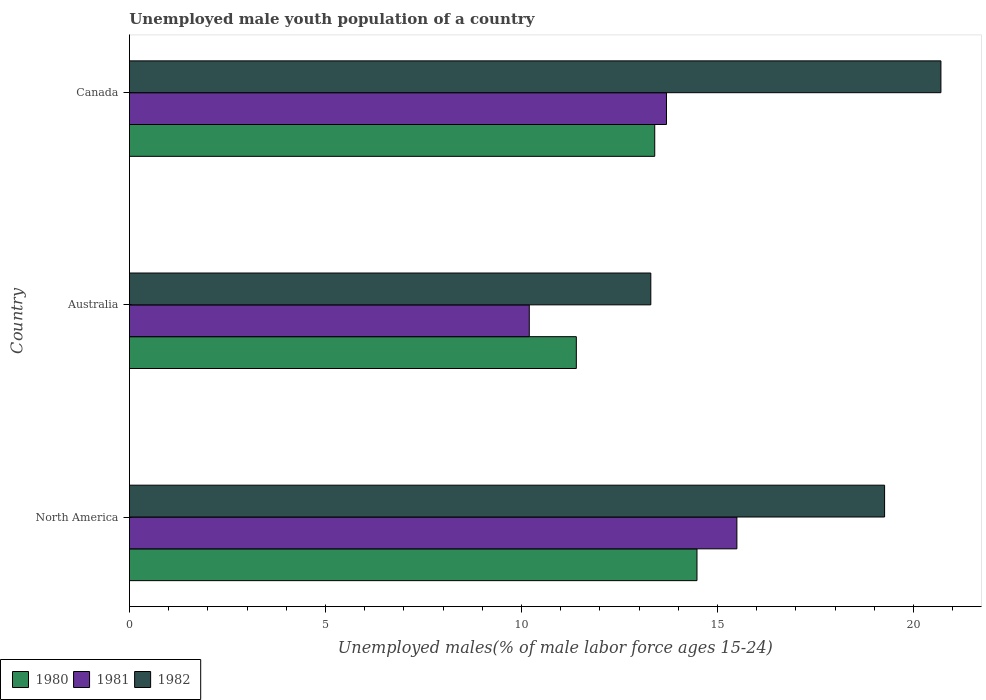How many different coloured bars are there?
Your answer should be very brief. 3. How many groups of bars are there?
Your answer should be very brief. 3. How many bars are there on the 1st tick from the top?
Your answer should be very brief. 3. What is the percentage of unemployed male youth population in 1980 in Australia?
Your answer should be compact. 11.4. Across all countries, what is the maximum percentage of unemployed male youth population in 1982?
Make the answer very short. 20.7. Across all countries, what is the minimum percentage of unemployed male youth population in 1981?
Ensure brevity in your answer.  10.2. What is the total percentage of unemployed male youth population in 1981 in the graph?
Ensure brevity in your answer.  39.4. What is the difference between the percentage of unemployed male youth population in 1982 in Australia and that in North America?
Provide a short and direct response. -5.96. What is the difference between the percentage of unemployed male youth population in 1981 in North America and the percentage of unemployed male youth population in 1980 in Australia?
Your response must be concise. 4.1. What is the average percentage of unemployed male youth population in 1980 per country?
Provide a short and direct response. 13.09. What is the difference between the percentage of unemployed male youth population in 1982 and percentage of unemployed male youth population in 1980 in North America?
Your answer should be very brief. 4.79. In how many countries, is the percentage of unemployed male youth population in 1980 greater than 16 %?
Keep it short and to the point. 0. What is the ratio of the percentage of unemployed male youth population in 1980 in Canada to that in North America?
Ensure brevity in your answer.  0.93. What is the difference between the highest and the second highest percentage of unemployed male youth population in 1982?
Make the answer very short. 1.44. What is the difference between the highest and the lowest percentage of unemployed male youth population in 1982?
Your answer should be very brief. 7.4. Is the sum of the percentage of unemployed male youth population in 1981 in Australia and North America greater than the maximum percentage of unemployed male youth population in 1980 across all countries?
Provide a short and direct response. Yes. Does the graph contain grids?
Offer a very short reply. No. Where does the legend appear in the graph?
Make the answer very short. Bottom left. How many legend labels are there?
Keep it short and to the point. 3. How are the legend labels stacked?
Offer a terse response. Horizontal. What is the title of the graph?
Provide a succinct answer. Unemployed male youth population of a country. Does "1979" appear as one of the legend labels in the graph?
Keep it short and to the point. No. What is the label or title of the X-axis?
Provide a succinct answer. Unemployed males(% of male labor force ages 15-24). What is the Unemployed males(% of male labor force ages 15-24) of 1980 in North America?
Offer a very short reply. 14.48. What is the Unemployed males(% of male labor force ages 15-24) of 1981 in North America?
Offer a terse response. 15.5. What is the Unemployed males(% of male labor force ages 15-24) of 1982 in North America?
Provide a succinct answer. 19.26. What is the Unemployed males(% of male labor force ages 15-24) in 1980 in Australia?
Your response must be concise. 11.4. What is the Unemployed males(% of male labor force ages 15-24) of 1981 in Australia?
Your answer should be compact. 10.2. What is the Unemployed males(% of male labor force ages 15-24) in 1982 in Australia?
Offer a very short reply. 13.3. What is the Unemployed males(% of male labor force ages 15-24) of 1980 in Canada?
Provide a short and direct response. 13.4. What is the Unemployed males(% of male labor force ages 15-24) of 1981 in Canada?
Make the answer very short. 13.7. What is the Unemployed males(% of male labor force ages 15-24) in 1982 in Canada?
Make the answer very short. 20.7. Across all countries, what is the maximum Unemployed males(% of male labor force ages 15-24) of 1980?
Your response must be concise. 14.48. Across all countries, what is the maximum Unemployed males(% of male labor force ages 15-24) in 1981?
Offer a very short reply. 15.5. Across all countries, what is the maximum Unemployed males(% of male labor force ages 15-24) in 1982?
Provide a succinct answer. 20.7. Across all countries, what is the minimum Unemployed males(% of male labor force ages 15-24) in 1980?
Give a very brief answer. 11.4. Across all countries, what is the minimum Unemployed males(% of male labor force ages 15-24) in 1981?
Ensure brevity in your answer.  10.2. Across all countries, what is the minimum Unemployed males(% of male labor force ages 15-24) of 1982?
Make the answer very short. 13.3. What is the total Unemployed males(% of male labor force ages 15-24) of 1980 in the graph?
Give a very brief answer. 39.28. What is the total Unemployed males(% of male labor force ages 15-24) of 1981 in the graph?
Your answer should be compact. 39.4. What is the total Unemployed males(% of male labor force ages 15-24) of 1982 in the graph?
Keep it short and to the point. 53.26. What is the difference between the Unemployed males(% of male labor force ages 15-24) of 1980 in North America and that in Australia?
Provide a succinct answer. 3.08. What is the difference between the Unemployed males(% of male labor force ages 15-24) of 1981 in North America and that in Australia?
Keep it short and to the point. 5.3. What is the difference between the Unemployed males(% of male labor force ages 15-24) in 1982 in North America and that in Australia?
Your response must be concise. 5.96. What is the difference between the Unemployed males(% of male labor force ages 15-24) of 1980 in North America and that in Canada?
Offer a very short reply. 1.08. What is the difference between the Unemployed males(% of male labor force ages 15-24) in 1981 in North America and that in Canada?
Provide a succinct answer. 1.8. What is the difference between the Unemployed males(% of male labor force ages 15-24) in 1982 in North America and that in Canada?
Make the answer very short. -1.44. What is the difference between the Unemployed males(% of male labor force ages 15-24) of 1980 in North America and the Unemployed males(% of male labor force ages 15-24) of 1981 in Australia?
Offer a very short reply. 4.28. What is the difference between the Unemployed males(% of male labor force ages 15-24) in 1980 in North America and the Unemployed males(% of male labor force ages 15-24) in 1982 in Australia?
Give a very brief answer. 1.18. What is the difference between the Unemployed males(% of male labor force ages 15-24) of 1981 in North America and the Unemployed males(% of male labor force ages 15-24) of 1982 in Australia?
Make the answer very short. 2.2. What is the difference between the Unemployed males(% of male labor force ages 15-24) in 1980 in North America and the Unemployed males(% of male labor force ages 15-24) in 1981 in Canada?
Your answer should be compact. 0.78. What is the difference between the Unemployed males(% of male labor force ages 15-24) in 1980 in North America and the Unemployed males(% of male labor force ages 15-24) in 1982 in Canada?
Make the answer very short. -6.22. What is the difference between the Unemployed males(% of male labor force ages 15-24) in 1981 in North America and the Unemployed males(% of male labor force ages 15-24) in 1982 in Canada?
Your response must be concise. -5.2. What is the difference between the Unemployed males(% of male labor force ages 15-24) in 1980 in Australia and the Unemployed males(% of male labor force ages 15-24) in 1981 in Canada?
Provide a short and direct response. -2.3. What is the average Unemployed males(% of male labor force ages 15-24) in 1980 per country?
Offer a terse response. 13.09. What is the average Unemployed males(% of male labor force ages 15-24) of 1981 per country?
Offer a terse response. 13.13. What is the average Unemployed males(% of male labor force ages 15-24) in 1982 per country?
Your answer should be compact. 17.75. What is the difference between the Unemployed males(% of male labor force ages 15-24) in 1980 and Unemployed males(% of male labor force ages 15-24) in 1981 in North America?
Your answer should be very brief. -1.02. What is the difference between the Unemployed males(% of male labor force ages 15-24) in 1980 and Unemployed males(% of male labor force ages 15-24) in 1982 in North America?
Your answer should be compact. -4.79. What is the difference between the Unemployed males(% of male labor force ages 15-24) of 1981 and Unemployed males(% of male labor force ages 15-24) of 1982 in North America?
Your response must be concise. -3.77. What is the difference between the Unemployed males(% of male labor force ages 15-24) in 1980 and Unemployed males(% of male labor force ages 15-24) in 1982 in Australia?
Your answer should be very brief. -1.9. What is the difference between the Unemployed males(% of male labor force ages 15-24) in 1980 and Unemployed males(% of male labor force ages 15-24) in 1981 in Canada?
Give a very brief answer. -0.3. What is the difference between the Unemployed males(% of male labor force ages 15-24) in 1980 and Unemployed males(% of male labor force ages 15-24) in 1982 in Canada?
Make the answer very short. -7.3. What is the difference between the Unemployed males(% of male labor force ages 15-24) of 1981 and Unemployed males(% of male labor force ages 15-24) of 1982 in Canada?
Provide a short and direct response. -7. What is the ratio of the Unemployed males(% of male labor force ages 15-24) in 1980 in North America to that in Australia?
Ensure brevity in your answer.  1.27. What is the ratio of the Unemployed males(% of male labor force ages 15-24) of 1981 in North America to that in Australia?
Make the answer very short. 1.52. What is the ratio of the Unemployed males(% of male labor force ages 15-24) of 1982 in North America to that in Australia?
Offer a terse response. 1.45. What is the ratio of the Unemployed males(% of male labor force ages 15-24) in 1980 in North America to that in Canada?
Offer a terse response. 1.08. What is the ratio of the Unemployed males(% of male labor force ages 15-24) of 1981 in North America to that in Canada?
Keep it short and to the point. 1.13. What is the ratio of the Unemployed males(% of male labor force ages 15-24) of 1982 in North America to that in Canada?
Keep it short and to the point. 0.93. What is the ratio of the Unemployed males(% of male labor force ages 15-24) in 1980 in Australia to that in Canada?
Give a very brief answer. 0.85. What is the ratio of the Unemployed males(% of male labor force ages 15-24) in 1981 in Australia to that in Canada?
Make the answer very short. 0.74. What is the ratio of the Unemployed males(% of male labor force ages 15-24) in 1982 in Australia to that in Canada?
Offer a terse response. 0.64. What is the difference between the highest and the second highest Unemployed males(% of male labor force ages 15-24) of 1980?
Give a very brief answer. 1.08. What is the difference between the highest and the second highest Unemployed males(% of male labor force ages 15-24) in 1981?
Make the answer very short. 1.8. What is the difference between the highest and the second highest Unemployed males(% of male labor force ages 15-24) of 1982?
Offer a very short reply. 1.44. What is the difference between the highest and the lowest Unemployed males(% of male labor force ages 15-24) in 1980?
Your response must be concise. 3.08. What is the difference between the highest and the lowest Unemployed males(% of male labor force ages 15-24) in 1981?
Offer a terse response. 5.3. 